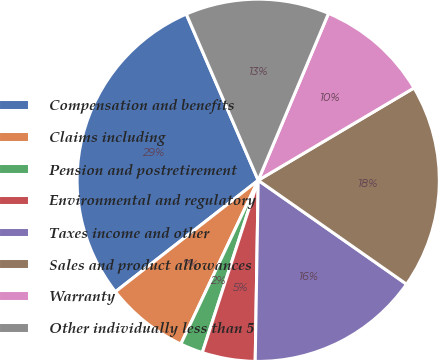Convert chart. <chart><loc_0><loc_0><loc_500><loc_500><pie_chart><fcel>Compensation and benefits<fcel>Claims including<fcel>Pension and postretirement<fcel>Environmental and regulatory<fcel>Taxes income and other<fcel>Sales and product allowances<fcel>Warranty<fcel>Other individually less than 5<nl><fcel>29.05%<fcel>7.43%<fcel>2.03%<fcel>4.73%<fcel>15.54%<fcel>18.24%<fcel>10.14%<fcel>12.84%<nl></chart> 